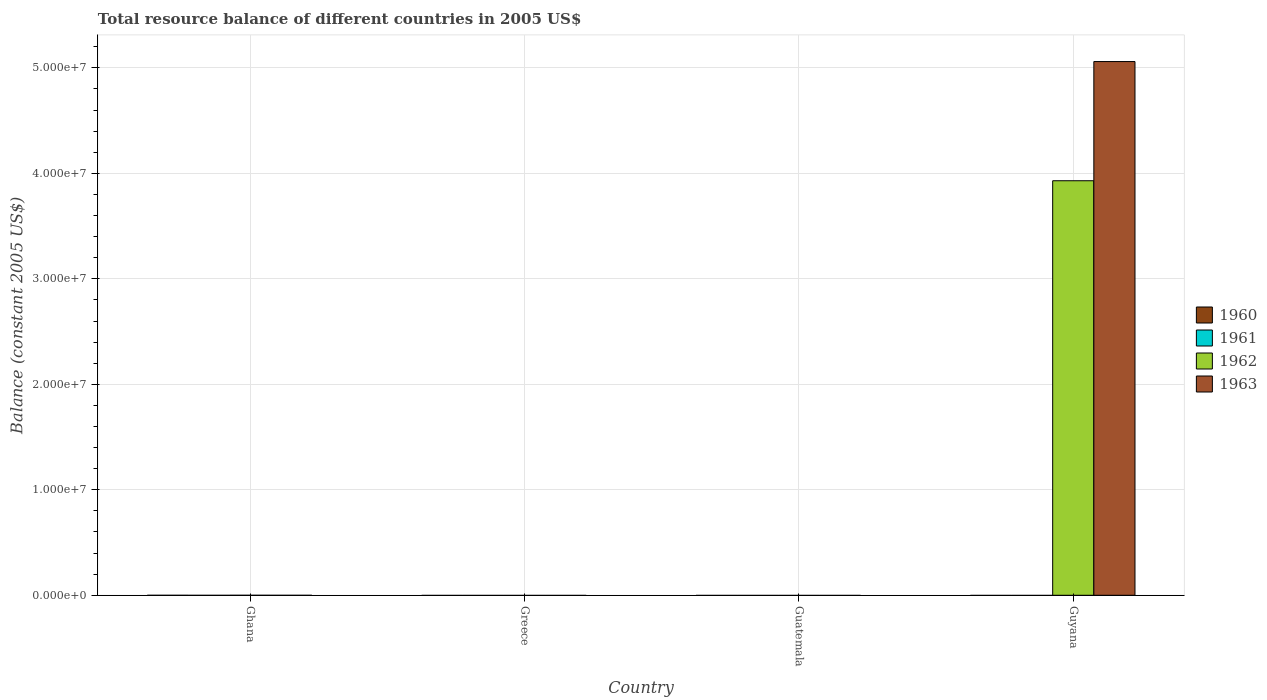How many different coloured bars are there?
Offer a very short reply. 2. Are the number of bars per tick equal to the number of legend labels?
Give a very brief answer. No. Are the number of bars on each tick of the X-axis equal?
Provide a succinct answer. No. How many bars are there on the 1st tick from the left?
Offer a terse response. 0. How many bars are there on the 1st tick from the right?
Your answer should be compact. 2. What is the label of the 2nd group of bars from the left?
Ensure brevity in your answer.  Greece. What is the total resource balance in 1961 in Ghana?
Offer a terse response. 0. Across all countries, what is the maximum total resource balance in 1962?
Provide a succinct answer. 3.93e+07. In which country was the total resource balance in 1963 maximum?
Offer a very short reply. Guyana. What is the total total resource balance in 1962 in the graph?
Provide a short and direct response. 3.93e+07. What is the difference between the total resource balance in 1960 in Ghana and the total resource balance in 1961 in Greece?
Make the answer very short. 0. What is the average total resource balance in 1962 per country?
Give a very brief answer. 9.82e+06. What is the difference between the highest and the lowest total resource balance in 1962?
Ensure brevity in your answer.  3.93e+07. In how many countries, is the total resource balance in 1960 greater than the average total resource balance in 1960 taken over all countries?
Ensure brevity in your answer.  0. Are all the bars in the graph horizontal?
Keep it short and to the point. No. What is the difference between two consecutive major ticks on the Y-axis?
Provide a succinct answer. 1.00e+07. Are the values on the major ticks of Y-axis written in scientific E-notation?
Provide a short and direct response. Yes. Does the graph contain any zero values?
Provide a succinct answer. Yes. Does the graph contain grids?
Your answer should be very brief. Yes. How are the legend labels stacked?
Give a very brief answer. Vertical. What is the title of the graph?
Your answer should be compact. Total resource balance of different countries in 2005 US$. Does "1989" appear as one of the legend labels in the graph?
Ensure brevity in your answer.  No. What is the label or title of the Y-axis?
Offer a very short reply. Balance (constant 2005 US$). What is the Balance (constant 2005 US$) of 1962 in Ghana?
Provide a short and direct response. 0. What is the Balance (constant 2005 US$) in 1963 in Ghana?
Your answer should be very brief. 0. What is the Balance (constant 2005 US$) of 1961 in Greece?
Give a very brief answer. 0. What is the Balance (constant 2005 US$) in 1962 in Greece?
Ensure brevity in your answer.  0. What is the Balance (constant 2005 US$) in 1961 in Guatemala?
Your answer should be very brief. 0. What is the Balance (constant 2005 US$) in 1962 in Guatemala?
Your response must be concise. 0. What is the Balance (constant 2005 US$) in 1960 in Guyana?
Ensure brevity in your answer.  0. What is the Balance (constant 2005 US$) in 1961 in Guyana?
Offer a terse response. 0. What is the Balance (constant 2005 US$) in 1962 in Guyana?
Make the answer very short. 3.93e+07. What is the Balance (constant 2005 US$) in 1963 in Guyana?
Provide a short and direct response. 5.06e+07. Across all countries, what is the maximum Balance (constant 2005 US$) of 1962?
Your response must be concise. 3.93e+07. Across all countries, what is the maximum Balance (constant 2005 US$) of 1963?
Your answer should be very brief. 5.06e+07. What is the total Balance (constant 2005 US$) of 1960 in the graph?
Offer a very short reply. 0. What is the total Balance (constant 2005 US$) of 1962 in the graph?
Your answer should be compact. 3.93e+07. What is the total Balance (constant 2005 US$) in 1963 in the graph?
Your response must be concise. 5.06e+07. What is the average Balance (constant 2005 US$) in 1961 per country?
Your answer should be very brief. 0. What is the average Balance (constant 2005 US$) in 1962 per country?
Your answer should be compact. 9.82e+06. What is the average Balance (constant 2005 US$) in 1963 per country?
Ensure brevity in your answer.  1.26e+07. What is the difference between the Balance (constant 2005 US$) in 1962 and Balance (constant 2005 US$) in 1963 in Guyana?
Provide a short and direct response. -1.13e+07. What is the difference between the highest and the lowest Balance (constant 2005 US$) of 1962?
Keep it short and to the point. 3.93e+07. What is the difference between the highest and the lowest Balance (constant 2005 US$) of 1963?
Provide a short and direct response. 5.06e+07. 